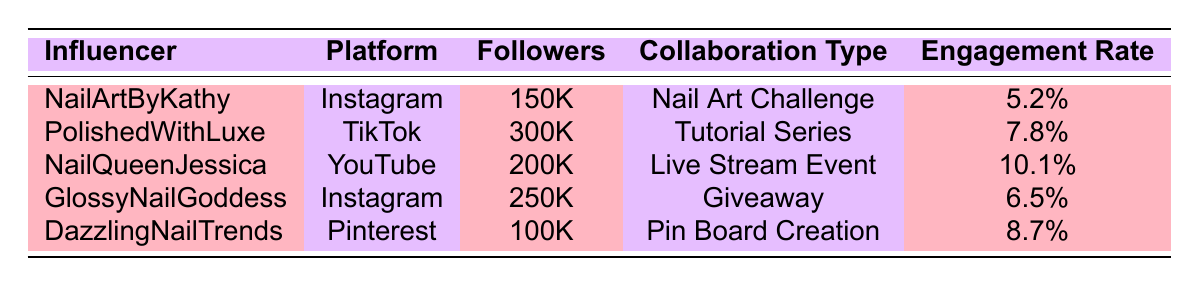What is the engagement rate of NailArtByKathy? The table lists NailArtByKathy's engagement rate directly as 5.2%.
Answer: 5.2% Which influencer has the highest number of followers? The table shows that PolishedWithLuxe has 300,000 followers, the highest among the influencers listed.
Answer: PolishedWithLuxe How many likes did NailQueenJessica receive? According to the table, NailQueenJessica received 8,000 likes, as stated in the respective row.
Answer: 8,000 Is the engagement rate of GlossyNailGoddess greater than 6%? The table indicates that GlossyNailGoddess has an engagement rate of 6.5%, which is greater than 6%.
Answer: Yes What is the average engagement rate of the influencers listed? To find the average, sum the engagement rates: (5.2 + 7.8 + 10.1 + 6.5 + 8.7) = 38.3. There are 5 influencers, so the average is 38.3 / 5 = 7.66.
Answer: 7.66 What is the total number of likes from all influencers? Adding the likes: 2,000 (Kathy) + 5,000 (Luxe) + 8,000 (Jessica) + 3,500 (Goddess) + 1,500 (Trends) = 20,000 total likes.
Answer: 20,000 Was the collaboration duration for NailArtByKathy longer than for DazzlingNailTrends? NailArtByKathy had a collaboration duration of 1 month, while DazzlingNailTrends had 1 month as well, making them equal.
Answer: No Which influencer's collaboration type has the highest engagement rate? NailQueenJessica had the highest engagement rate of 10.1% with a Live Stream Event collaboration type, according to the table.
Answer: NailQueenJessica How many comments did PolishedWithLuxe receive compared to GlossyNailGoddess? PolishedWithLuxe received 800 comments while GlossyNailGoddess received 450 comments. Thus, PolishedWithLuxe had 350 more comments.
Answer: 350 more comments What percentage of the total followers do the influencers on Instagram represent? The total number of followers is 150,000 (Kathy) + 250,000 (Goddess) = 400,000 for Instagram. The total followers across all influencers are 1,000,000 (150K + 300K + 200K + 250K + 100K). Therefore, (400,000 / 1,000,000) * 100 = 40%.
Answer: 40% 